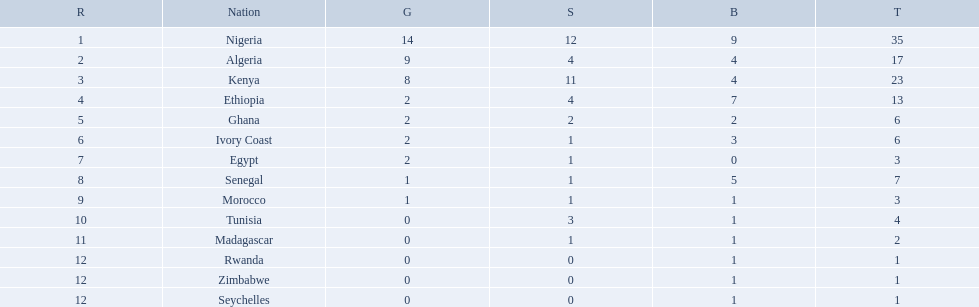Which nations competed in the 1989 african championships in athletics? Nigeria, Algeria, Kenya, Ethiopia, Ghana, Ivory Coast, Egypt, Senegal, Morocco, Tunisia, Madagascar, Rwanda, Zimbabwe, Seychelles. Of these nations, which earned 0 bronze medals? Egypt. 